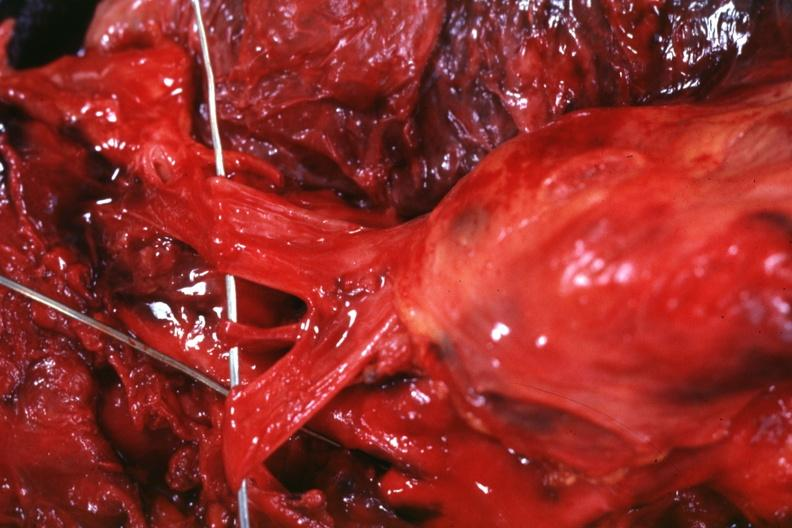s hematologic present?
Answer the question using a single word or phrase. Yes 